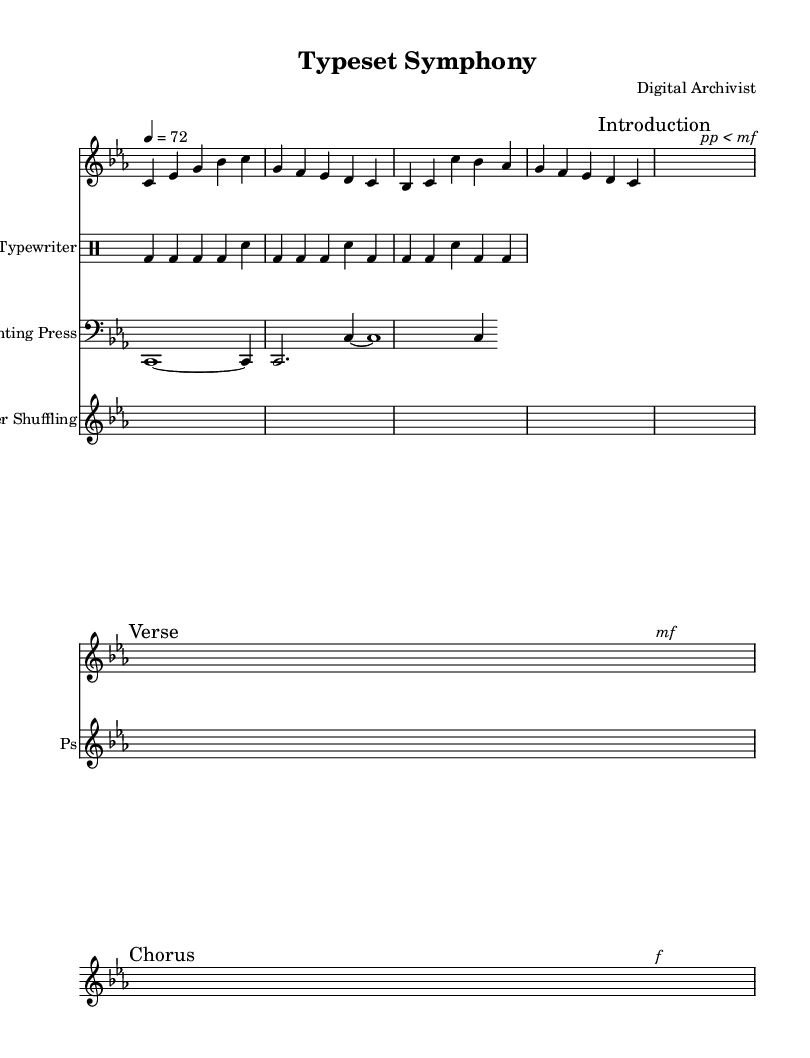What is the key signature of this music? The key signature is indicated at the beginning of the staff, showing three flats, which corresponds to C minor.
Answer: C minor What is the time signature of this composition? The time signature appears right after the key signature and is represented by the two numbers showing a number of beats in a measure. Here, it shows five beats per measure.
Answer: 5/4 What is the tempo marking for the piece? The tempo is notated in quarter note equals a specified number, and it is indicated at the beginning of the score, which is set to 72.
Answer: 72 How many different instruments are represented in the sheet music? By counting the distinct staves, we find there are four: one for the melody, one for the typewriter, one for the printing press, and one for paper shuffling.
Answer: Four Which section of the piece has a dynamic marking of "p" followed by "mf"? After the introduction, a specific dynamic marking indicates a change from piano to mezzo forte at the beginning of the verse section, as shown by the markings.
Answer: Verse What is the primary sound source used for the rhythmic part of this composition? The rhythmic section is indicated by the specific instrument name at the top of the drum staff, explicitly stating it is derived from the typewriter.
Answer: Typewriter What type of sound does the "printing press" section represent in the score? The notes in the printing press line are specifically labeled, suggesting sounds that resemble the functioning of a printing press, indicated by the distinct notational pattern used.
Answer: Printing Press 